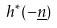<formula> <loc_0><loc_0><loc_500><loc_500>h ^ { * } ( - \underline { n } )</formula> 